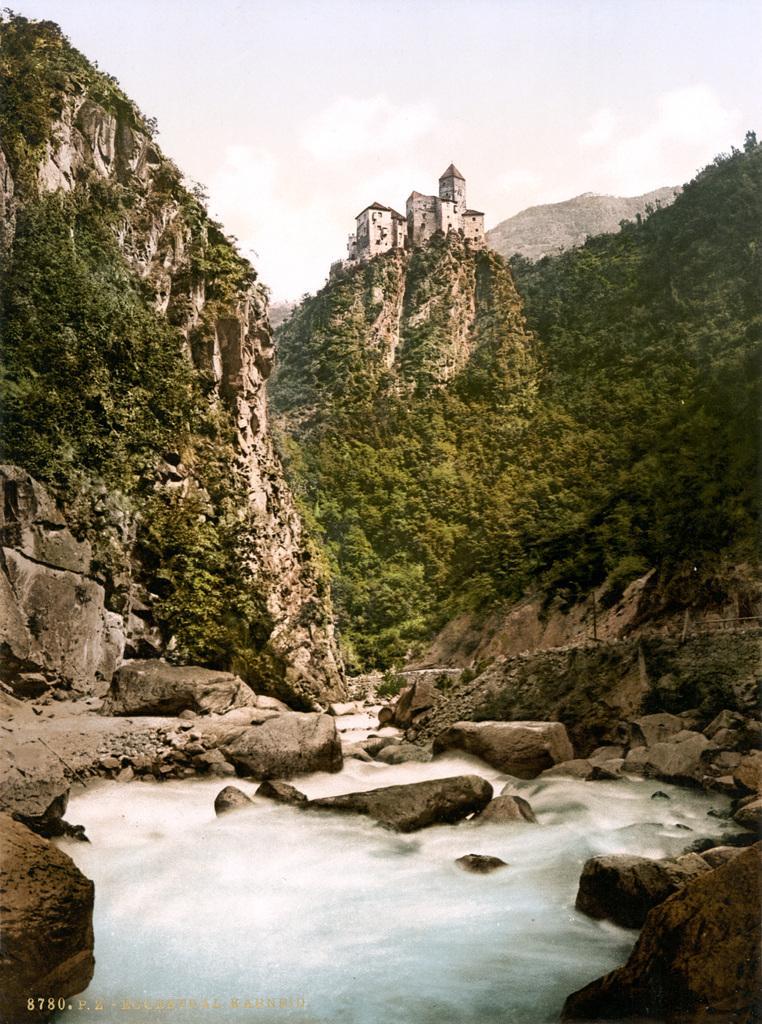Describe this image in one or two sentences. In this image there are water, trees, hills, building and the sky. 